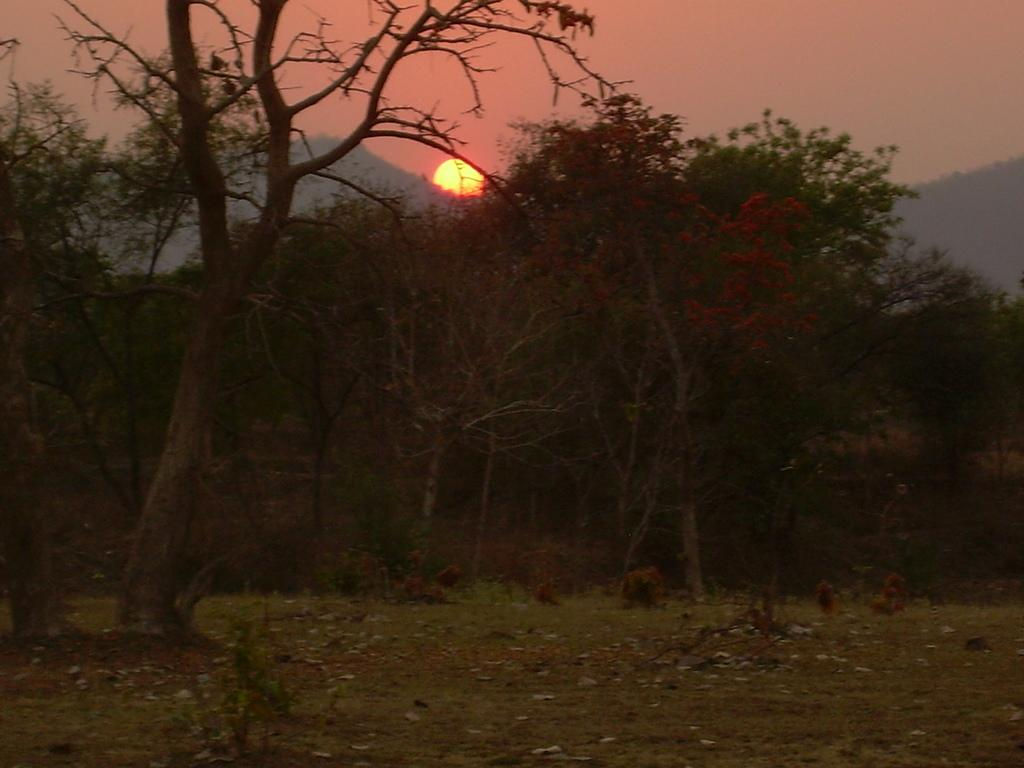What type of vegetation is present on the grass surface in the image? There are many trees on the grass surface in the image. What else can be seen on the grass surface besides the trees? There are dried leaves on the grass surface. What can be seen in the background of the image? There is a hill and the sun visible in the background of the image. What else is visible in the background of the image? The sky is visible in the background of the image. How many snakes are balancing on the trees in the image? There are no snakes present in the image, and therefore no snakes can be seen balancing on the trees. 